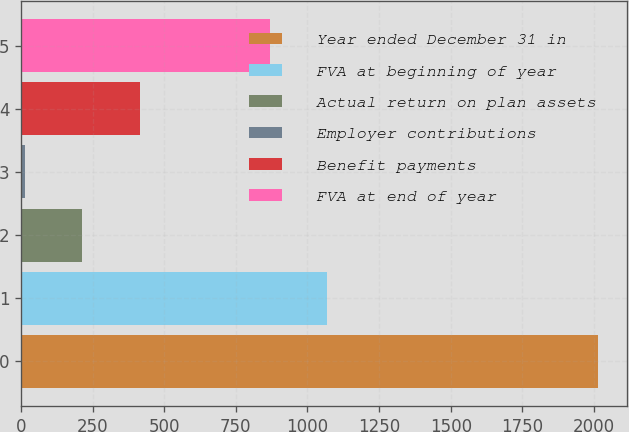Convert chart. <chart><loc_0><loc_0><loc_500><loc_500><bar_chart><fcel>Year ended December 31 in<fcel>FVA at beginning of year<fcel>Actual return on plan assets<fcel>Employer contributions<fcel>Benefit payments<fcel>FVA at end of year<nl><fcel>2015<fcel>1069.1<fcel>214.1<fcel>14<fcel>414.2<fcel>869<nl></chart> 